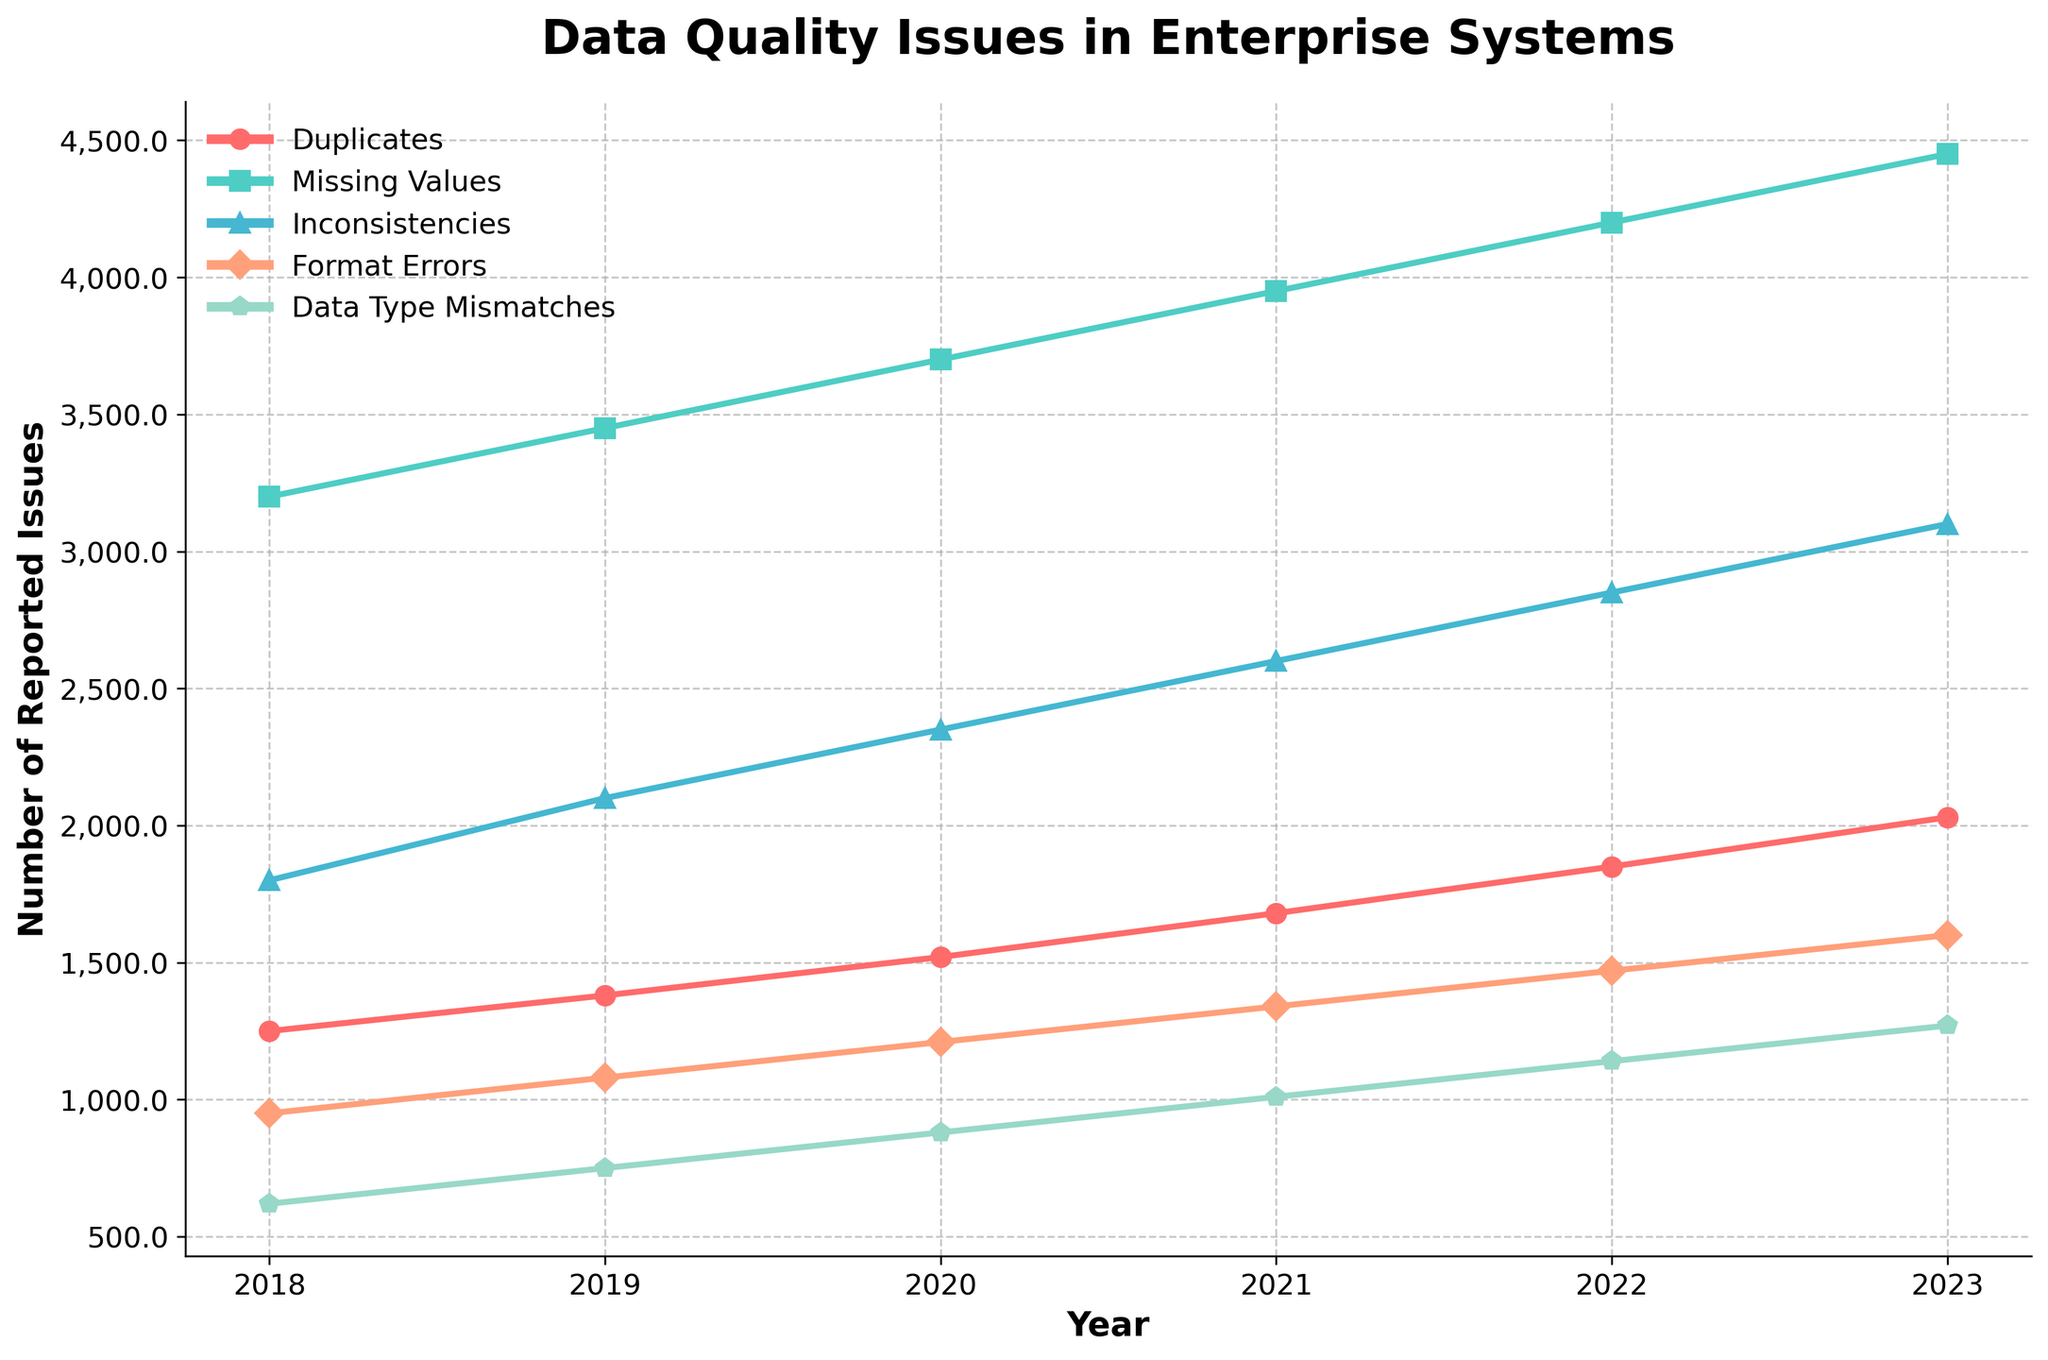What's the trend in the number of reported duplicates from 2018 to 2023? The number of reported duplicates has been increasing each year. It started at 1250 in 2018 and reached 2030 in 2023. This indicates a steady upward trend.
Answer: Increasing Which category had the highest number of reported issues each year? Each year, the category "Missing Values" has the highest number of reported issues. For example, in 2023, "Missing Values" reported 4450 issues, the highest among all categories.
Answer: Missing Values Between which two consecutive years did the inconsistencies category see the highest increase in reported issues? The number of reported inconsistencies increased by 250 between 2018 and 2019, by 250 between 2019 and 2020, by 250 between 2020 and 2021, by 250 between 2021 and 2022, and by 250 between 2022 and 2023. Thus, the increase is consistent each year, maintaining a 250 issues increase each year.
Answer: 2018 to 2019, 2019 to 2020, 2020 to 2021, 2021 to 2022, and 2022 to 2023 By how much did the number of format errors increase from 2018 to 2023? The number of format errors in 2018 was 950, and this increased to 1600 in 2023. The increase is calculated as 1600 - 950 = 650.
Answer: 650 Which category consistently shows the least number of reported issues over the years? "Data Type Mismatches" consistently has the least number of reported issues each year. For example, in 2023, there were 1270 reported issues for data type mismatches, the lowest among all categories.
Answer: Data Type Mismatches In what year did the 'Duplicates' category first exceed 1500 reported issues? The 'Duplicates' category first exceeded 1500 reported issues in 2020, when it reported 1520 issues.
Answer: 2020 Compare the number of reported 'Missing Values' issues in 2022 to that in 2020. Which year had more issues and by how much? In 2020, there were 3700 reported 'Missing Values' issues, and in 2022, there were 4200. The difference is calculated by 4200 - 3700 = 500. So, 2022 had 500 more issues than 2020.
Answer: 2022 by 500 Which category saw the lowest average yearly increase in reported issues from 2018 to 2023? Calculate the yearly increase for each category: Duplicates: (2030 - 1250) / 5 = 156; Missing Values: (4450 - 3200) / 5 = 250; Inconsistencies: (3100 - 1800) / 5 = 260; Format Errors: (1600 - 950) / 5 = 130; Data Type Mismatches: (1270 - 620) / 5 = 130. 'Format Errors' and 'Data Type Mismatches' have the lowest average yearly increase of 130 issues.
Answer: Format Errors and Data Type Mismatches How did the total number of reported issues across all categories change from 2018 to 2023? Sum the reported issues for each year and compare: 2018: 1250 + 3200 + 1800 + 950 + 620 = 7820; 2023: 2030 + 4450 + 3100 + 1600 + 1270 = 12450. The increase is 12450 - 7820 = 4630.
Answer: Increased by 4630 